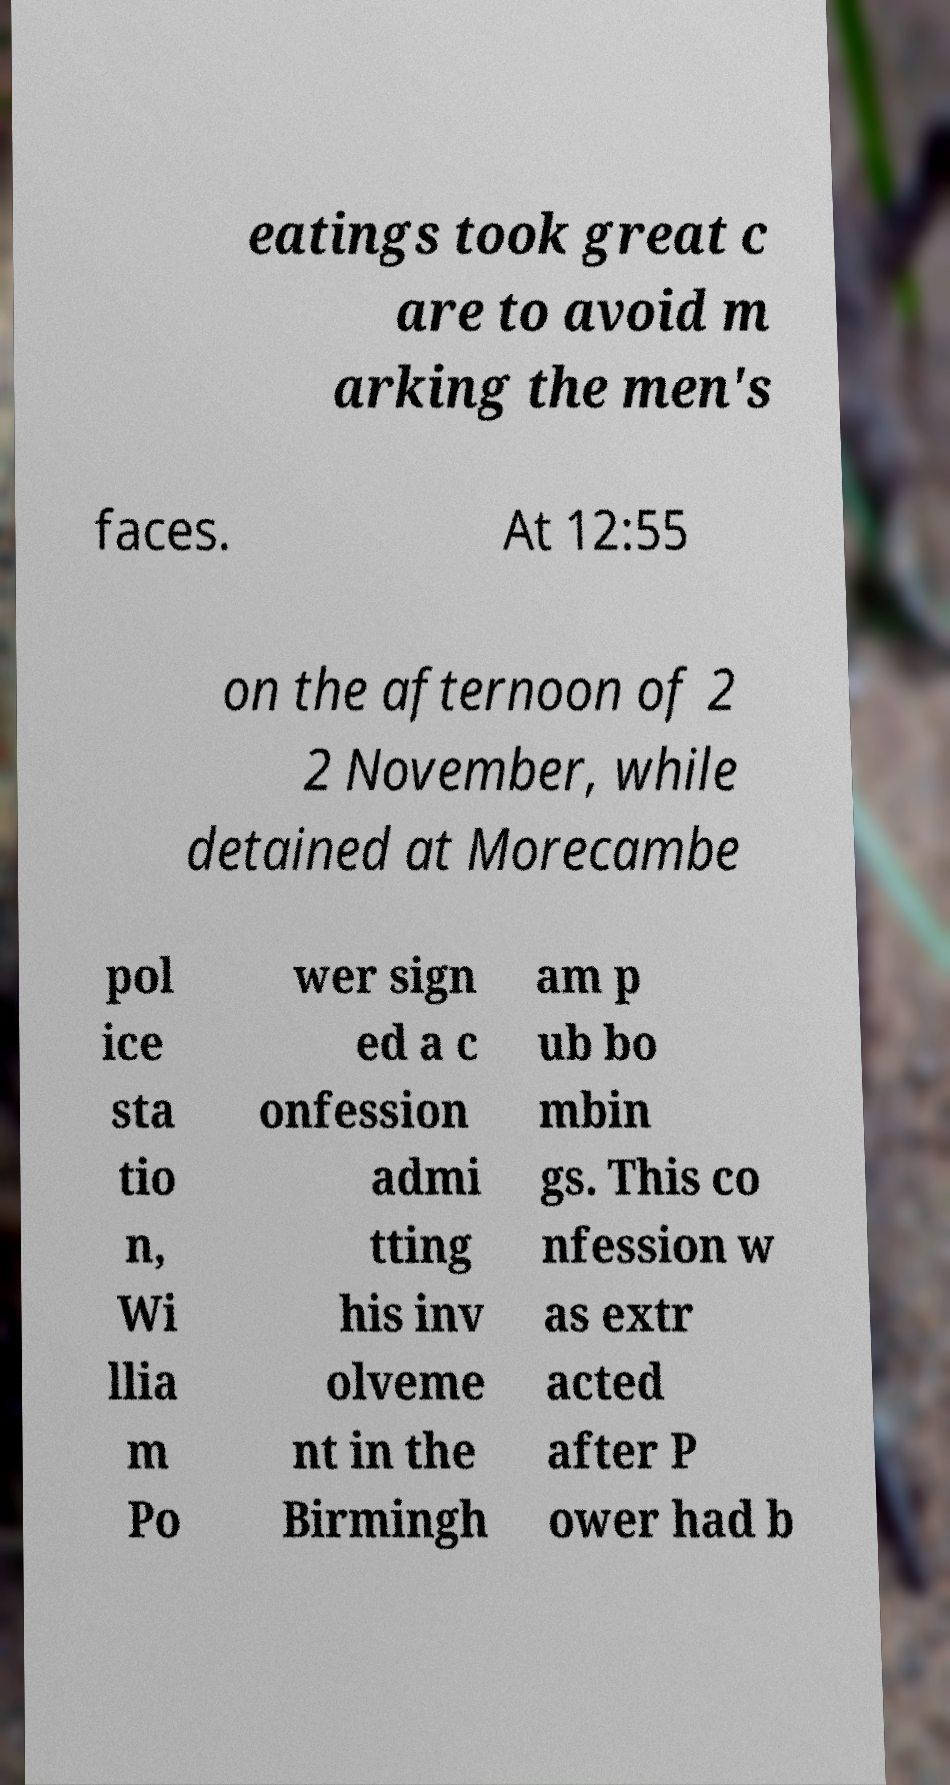Please read and relay the text visible in this image. What does it say? eatings took great c are to avoid m arking the men's faces. At 12:55 on the afternoon of 2 2 November, while detained at Morecambe pol ice sta tio n, Wi llia m Po wer sign ed a c onfession admi tting his inv olveme nt in the Birmingh am p ub bo mbin gs. This co nfession w as extr acted after P ower had b 